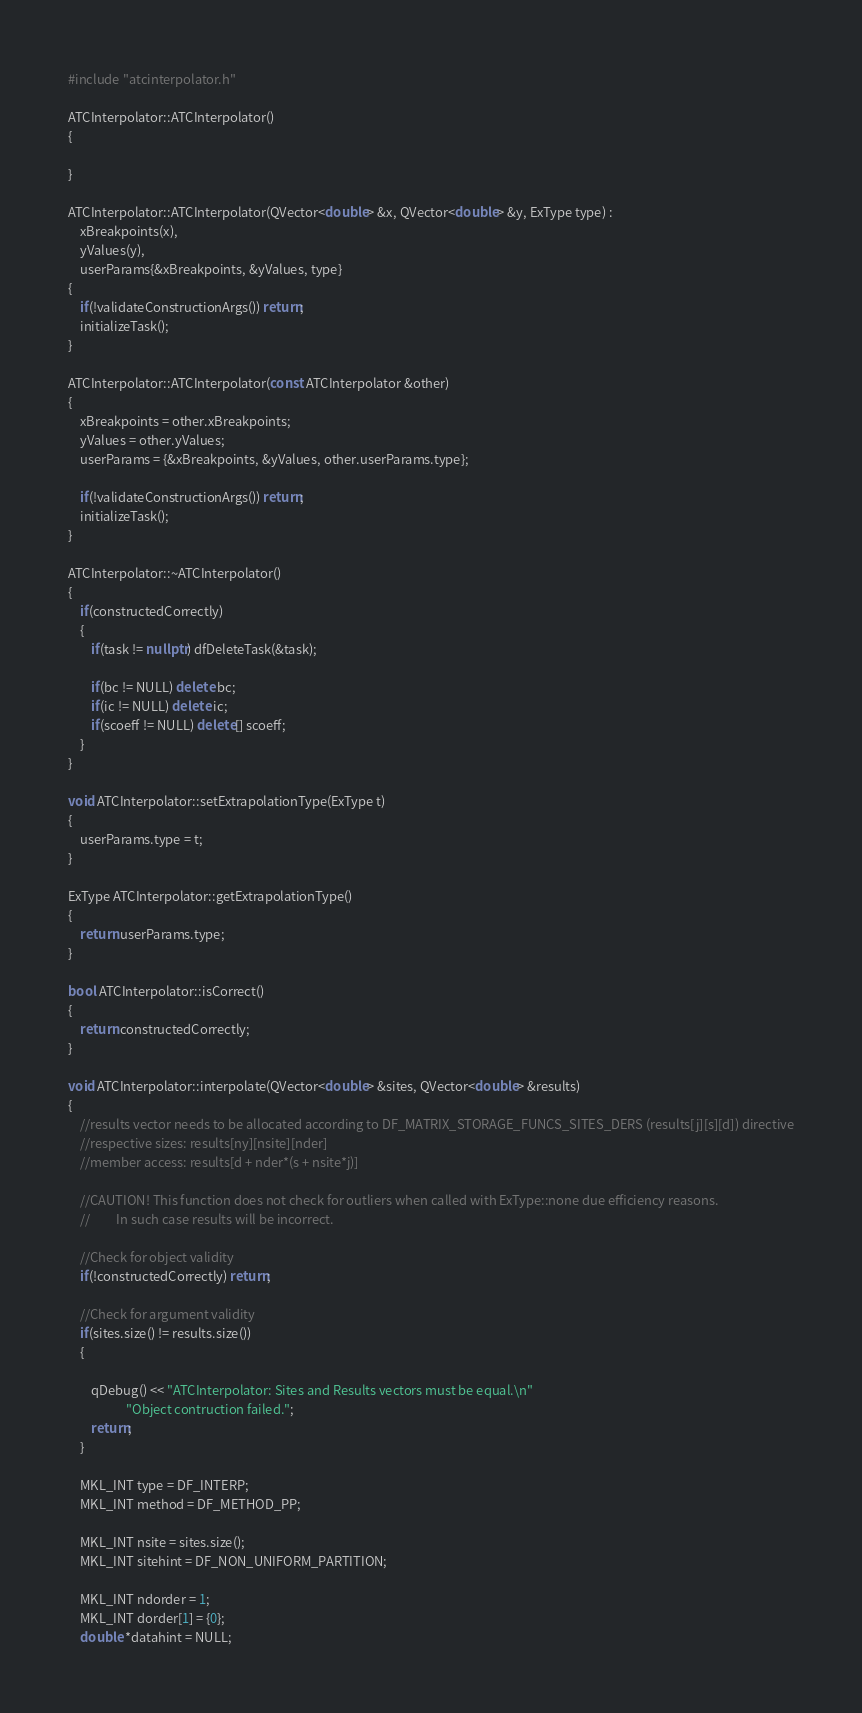<code> <loc_0><loc_0><loc_500><loc_500><_C++_>
#include "atcinterpolator.h"

ATCInterpolator::ATCInterpolator()
{

}

ATCInterpolator::ATCInterpolator(QVector<double> &x, QVector<double> &y, ExType type) :
    xBreakpoints(x),
    yValues(y),
    userParams{&xBreakpoints, &yValues, type}
{
    if(!validateConstructionArgs()) return;
    initializeTask();
}

ATCInterpolator::ATCInterpolator(const ATCInterpolator &other)
{
    xBreakpoints = other.xBreakpoints;
    yValues = other.yValues;
    userParams = {&xBreakpoints, &yValues, other.userParams.type};

    if(!validateConstructionArgs()) return;
    initializeTask();
}

ATCInterpolator::~ATCInterpolator()
{
    if(constructedCorrectly)
    {
        if(task != nullptr) dfDeleteTask(&task);

        if(bc != NULL) delete bc;
        if(ic != NULL) delete ic;
        if(scoeff != NULL) delete[] scoeff;
    }
}

void ATCInterpolator::setExtrapolationType(ExType t)
{
    userParams.type = t;
}

ExType ATCInterpolator::getExtrapolationType()
{
    return userParams.type;
}

bool ATCInterpolator::isCorrect()
{
    return constructedCorrectly;
}

void ATCInterpolator::interpolate(QVector<double> &sites, QVector<double> &results)
{
    //results vector needs to be allocated according to DF_MATRIX_STORAGE_FUNCS_SITES_DERS (results[j][s][d]) directive
    //respective sizes: results[ny][nsite][nder]
    //member access: results[d + nder*(s + nsite*j)]

    //CAUTION! This function does not check for outliers when called with ExType::none due efficiency reasons.
    //         In such case results will be incorrect.

    //Check for object validity
    if(!constructedCorrectly) return;

    //Check for argument validity
    if(sites.size() != results.size())
    {

        qDebug() << "ATCInterpolator: Sites and Results vectors must be equal.\n"
                    "Object contruction failed.";
        return;
    }

    MKL_INT type = DF_INTERP;
    MKL_INT method = DF_METHOD_PP;

    MKL_INT nsite = sites.size();
    MKL_INT sitehint = DF_NON_UNIFORM_PARTITION;

    MKL_INT ndorder = 1;
    MKL_INT dorder[1] = {0};
    double *datahint = NULL;
</code> 